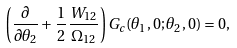Convert formula to latex. <formula><loc_0><loc_0><loc_500><loc_500>\left ( \frac { \partial } { \partial \theta _ { 2 } } + \frac { 1 } { 2 } \, \frac { W _ { 1 2 } } { \Omega _ { 1 2 } } \right ) G _ { c } ( \theta _ { 1 } , 0 ; \theta _ { 2 } , 0 ) = 0 ,</formula> 